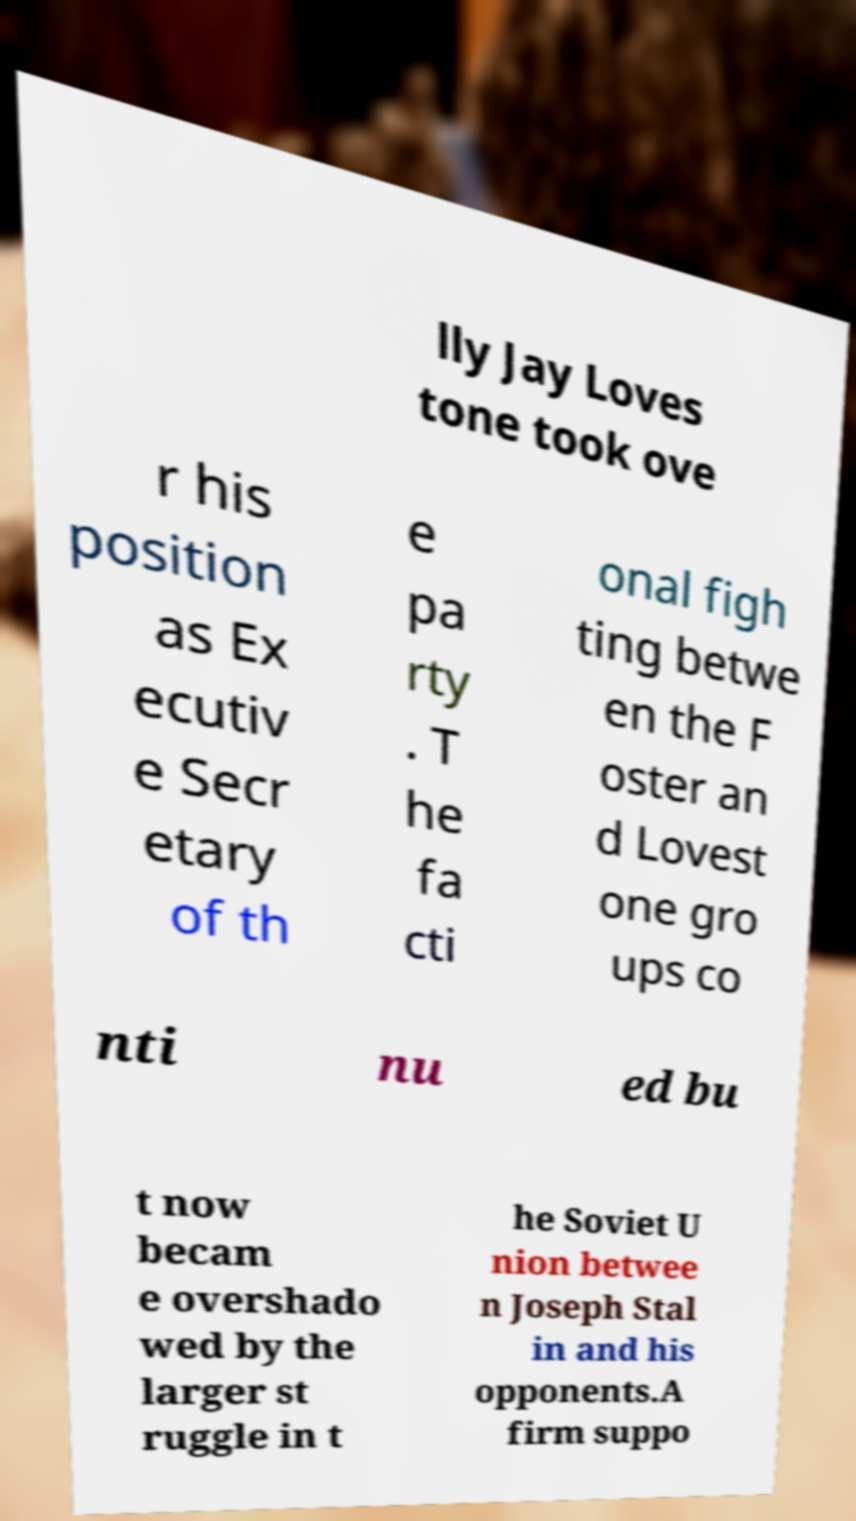There's text embedded in this image that I need extracted. Can you transcribe it verbatim? lly Jay Loves tone took ove r his position as Ex ecutiv e Secr etary of th e pa rty . T he fa cti onal figh ting betwe en the F oster an d Lovest one gro ups co nti nu ed bu t now becam e overshado wed by the larger st ruggle in t he Soviet U nion betwee n Joseph Stal in and his opponents.A firm suppo 